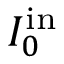Convert formula to latex. <formula><loc_0><loc_0><loc_500><loc_500>I _ { 0 } ^ { i n }</formula> 